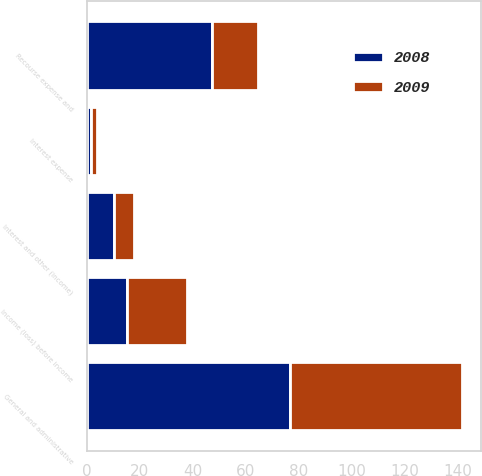<chart> <loc_0><loc_0><loc_500><loc_500><stacked_bar_chart><ecel><fcel>Recourse expense and<fcel>General and administrative<fcel>Interest expense<fcel>Interest and other (income)<fcel>Income (loss) before income<nl><fcel>2008<fcel>47.2<fcel>76.7<fcel>1.5<fcel>10.2<fcel>15.2<nl><fcel>2009<fcel>17.4<fcel>64.9<fcel>2.4<fcel>7.4<fcel>22.7<nl></chart> 